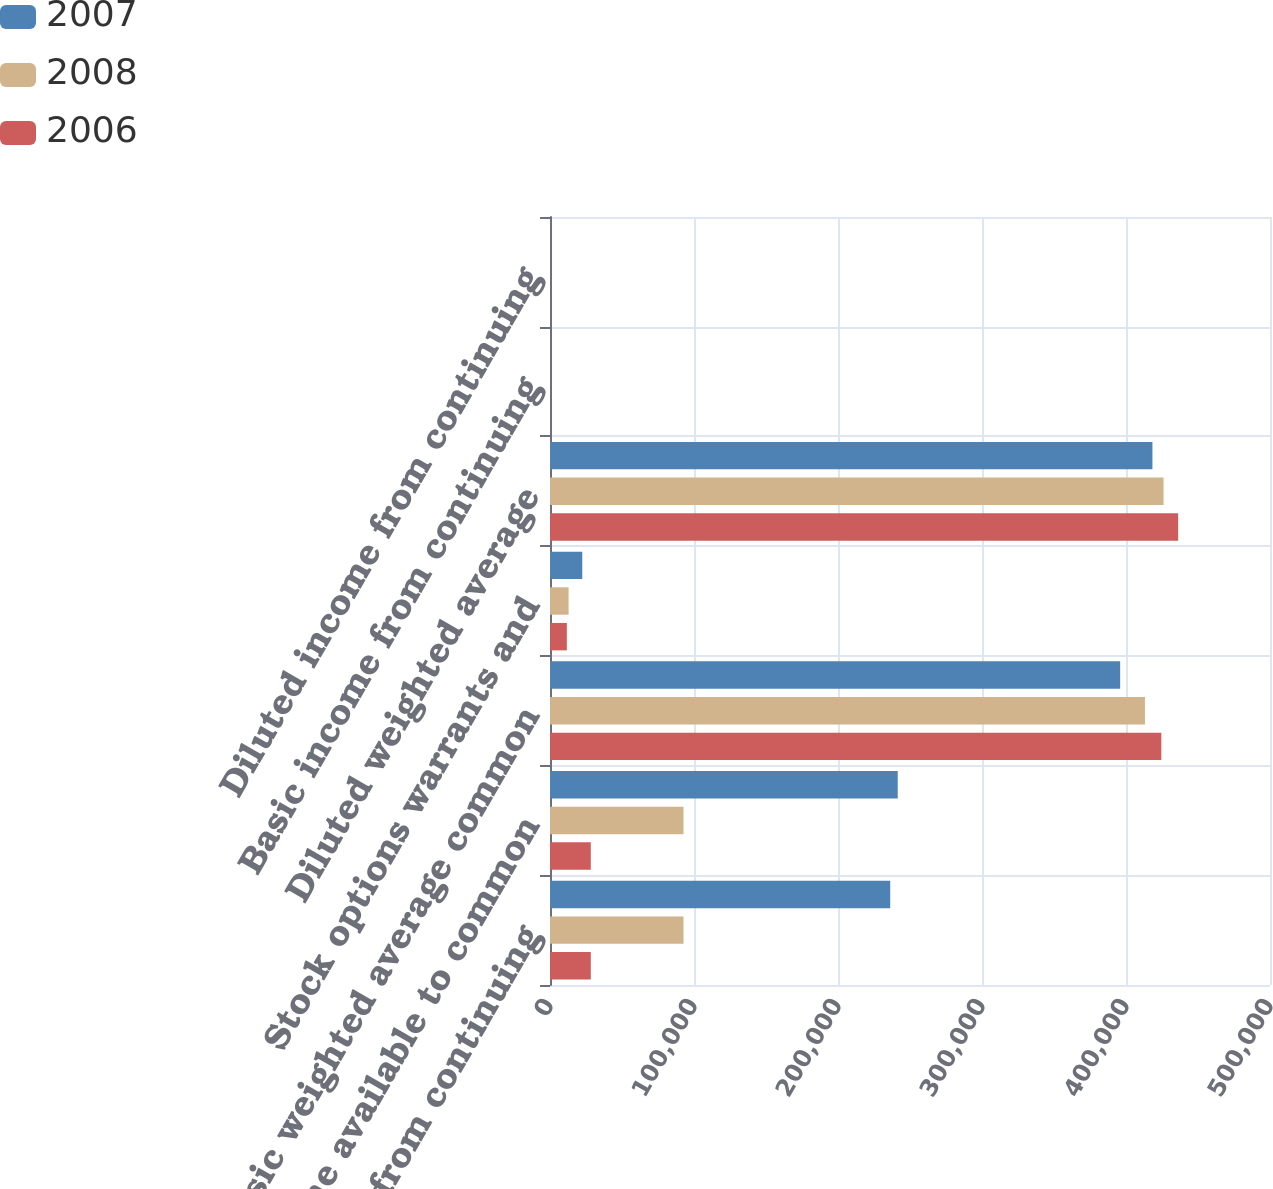Convert chart. <chart><loc_0><loc_0><loc_500><loc_500><stacked_bar_chart><ecel><fcel>Income from continuing<fcel>Income available to common<fcel>Basic weighted average common<fcel>Stock options warrants and<fcel>Diluted weighted average<fcel>Basic income from continuing<fcel>Diluted income from continuing<nl><fcel>2007<fcel>236264<fcel>241488<fcel>395947<fcel>22410<fcel>418357<fcel>0.6<fcel>0.58<nl><fcel>2008<fcel>92712<fcel>92712<fcel>413167<fcel>12912<fcel>426079<fcel>0.22<fcel>0.22<nl><fcel>2006<fcel>28338<fcel>28338<fcel>424525<fcel>11692<fcel>436217<fcel>0.06<fcel>0.06<nl></chart> 